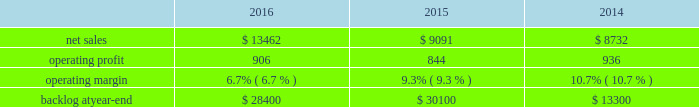2015 compared to 2014 mfc 2019s net sales in 2015 decreased $ 322 million , or 5% ( 5 % ) , compared to the same period in 2014 .
The decrease was attributable to lower net sales of approximately $ 345 million for air and missile defense programs due to fewer deliveries ( primarily pac-3 ) and lower volume ( primarily thaad ) ; and approximately $ 85 million for tactical missile programs due to fewer deliveries ( primarily guided multiple launch rocket system ( gmlrs ) ) and joint air-to-surface standoff missile , partially offset by increased deliveries for hellfire .
These decreases were partially offset by higher net sales of approximately $ 55 million for energy solutions programs due to increased volume .
Mfc 2019s operating profit in 2015 decreased $ 62 million , or 5% ( 5 % ) , compared to 2014 .
The decrease was attributable to lower operating profit of approximately $ 100 million for fire control programs due primarily to lower risk retirements ( primarily lantirn and sniper ) ; and approximately $ 65 million for tactical missile programs due to lower risk retirements ( primarily hellfire and gmlrs ) and fewer deliveries .
These decreases were partially offset by higher operating profit of approximately $ 75 million for air and missile defense programs due to increased risk retirements ( primarily thaad ) .
Adjustments not related to volume , including net profit booking rate adjustments and other matters , were approximately $ 60 million lower in 2015 compared to 2014 .
Backlog backlog decreased in 2016 compared to 2015 primarily due to lower orders on pac-3 , hellfire , and jassm .
Backlog increased in 2015 compared to 2014 primarily due to higher orders on pac-3 , lantirn/sniper and certain tactical missile programs , partially offset by lower orders on thaad .
Trends we expect mfc 2019s net sales to increase in the mid-single digit percentage range in 2017 as compared to 2016 driven primarily by our air and missile defense programs .
Operating profit is expected to be flat or increase slightly .
Accordingly , operating profit margin is expected to decline from 2016 levels as a result of contract mix and fewer risk retirements in 2017 compared to 2016 .
Rotary and mission systems as previously described , on november 6 , 2015 , we acquired sikorsky and aligned the sikorsky business under our rms business segment .
The 2015 results of the acquired sikorsky business have been included in our financial results from the november 6 , 2015 acquisition date through december 31 , 2015 .
As a result , our consolidated operating results and rms business segment operating results for the year ended december 31 , 2015 do not reflect a full year of sikorsky operations .
Our rms business segment provides design , manufacture , service and support for a variety of military and civil helicopters , ship and submarine mission and combat systems ; mission systems and sensors for rotary and fixed-wing aircraft ; sea and land-based missile defense systems ; radar systems ; the littoral combat ship ( lcs ) ; simulation and training services ; and unmanned systems and technologies .
In addition , rms supports the needs of government customers in cybersecurity and delivers communication and command and control capabilities through complex mission solutions for defense applications .
Rms 2019 major programs include black hawk and seahawk helicopters , aegis combat system ( aegis ) , lcs , space fence , advanced hawkeye radar system , tpq-53 radar system , ch-53k development helicopter , and vh-92a helicopter program .
Rms 2019 operating results included the following ( in millions ) : .
2016 compared to 2015 rms 2019 net sales in 2016 increased $ 4.4 billion , or 48% ( 48 % ) , compared to 2015 .
The increase was primarily attributable to higher net sales of approximately $ 4.6 billion from sikorsky , which was acquired on november 6 , 2015 .
Net sales for 2015 include sikorsky 2019s results subsequent to the acquisition date , net of certain revenue adjustments required to account for the acquisition of this business .
This increase was partially offset by lower net sales of approximately $ 70 million for training .
What is the growth rate of operating expenses from 2015 to 2016? 
Computations: (((13462 - 906) - (9091 - 844)) / (9091 - 844))
Answer: 0.52249. 